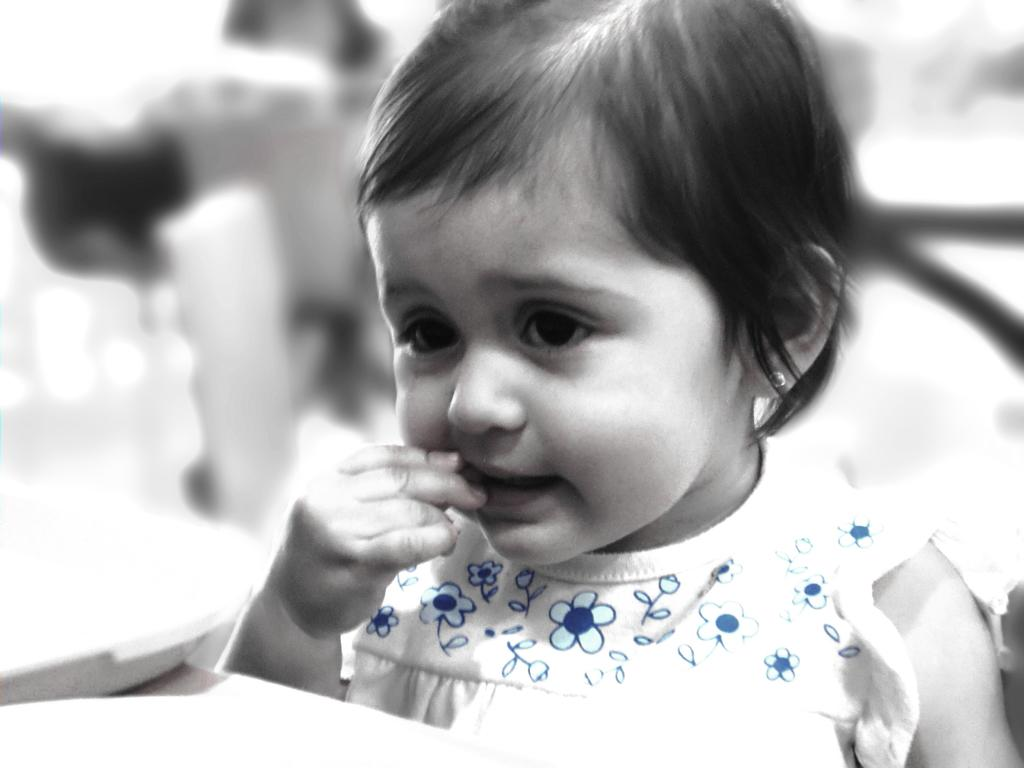Who is the main subject in the image? There is a girl in the image. What is the girl doing with her hand? The girl is holding something in her hand and keeping her hand in her mouth. Can you describe the background of the image? The background of the image is blurred. What type of knowledge can be gained from the rain in the image? There is no rain present in the image, so no knowledge can be gained from it. 